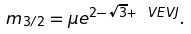Convert formula to latex. <formula><loc_0><loc_0><loc_500><loc_500>m _ { 3 / 2 } = \mu e ^ { 2 - \sqrt { 3 } + \ V E V { J } } .</formula> 